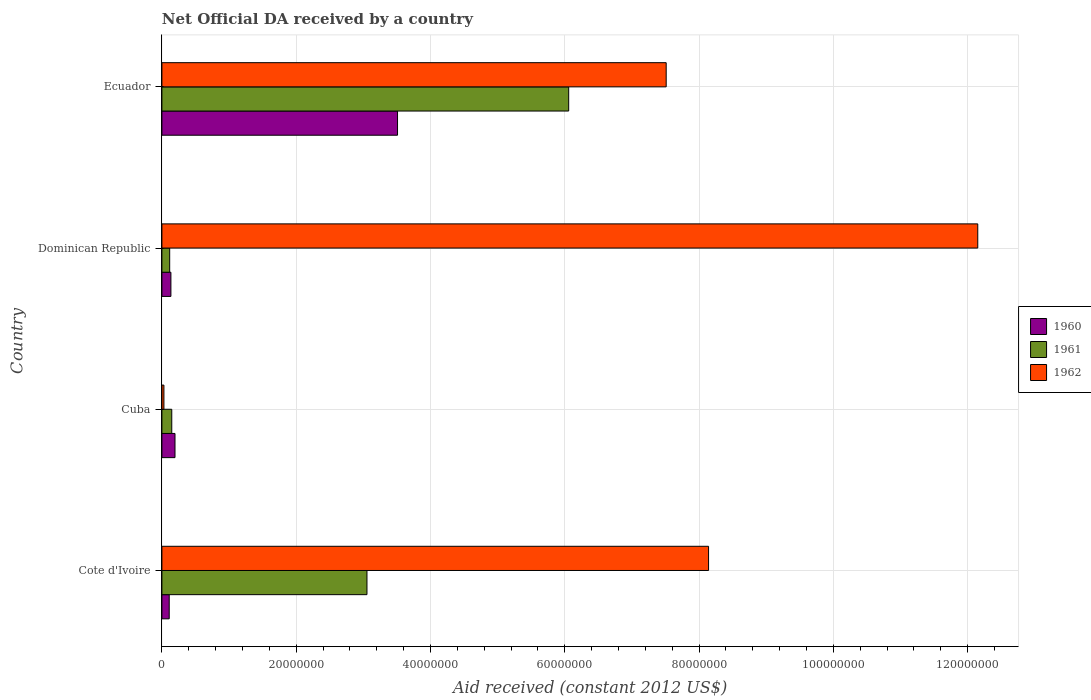How many groups of bars are there?
Provide a succinct answer. 4. How many bars are there on the 3rd tick from the bottom?
Your response must be concise. 3. What is the label of the 2nd group of bars from the top?
Your answer should be very brief. Dominican Republic. In how many cases, is the number of bars for a given country not equal to the number of legend labels?
Keep it short and to the point. 0. What is the net official development assistance aid received in 1960 in Dominican Republic?
Offer a terse response. 1.34e+06. Across all countries, what is the maximum net official development assistance aid received in 1960?
Offer a very short reply. 3.51e+07. Across all countries, what is the minimum net official development assistance aid received in 1961?
Your response must be concise. 1.16e+06. In which country was the net official development assistance aid received in 1961 maximum?
Provide a short and direct response. Ecuador. In which country was the net official development assistance aid received in 1962 minimum?
Give a very brief answer. Cuba. What is the total net official development assistance aid received in 1961 in the graph?
Ensure brevity in your answer.  9.38e+07. What is the difference between the net official development assistance aid received in 1961 in Cuba and that in Dominican Republic?
Provide a short and direct response. 3.10e+05. What is the difference between the net official development assistance aid received in 1960 in Cuba and the net official development assistance aid received in 1962 in Ecuador?
Offer a very short reply. -7.32e+07. What is the average net official development assistance aid received in 1962 per country?
Offer a terse response. 6.96e+07. What is the ratio of the net official development assistance aid received in 1960 in Cote d'Ivoire to that in Ecuador?
Give a very brief answer. 0.03. What is the difference between the highest and the second highest net official development assistance aid received in 1960?
Provide a short and direct response. 3.31e+07. What is the difference between the highest and the lowest net official development assistance aid received in 1960?
Your answer should be compact. 3.40e+07. Is the sum of the net official development assistance aid received in 1962 in Dominican Republic and Ecuador greater than the maximum net official development assistance aid received in 1960 across all countries?
Your answer should be very brief. Yes. Are all the bars in the graph horizontal?
Offer a terse response. Yes. How many countries are there in the graph?
Your answer should be compact. 4. What is the difference between two consecutive major ticks on the X-axis?
Offer a very short reply. 2.00e+07. Where does the legend appear in the graph?
Ensure brevity in your answer.  Center right. How many legend labels are there?
Your answer should be compact. 3. How are the legend labels stacked?
Provide a short and direct response. Vertical. What is the title of the graph?
Keep it short and to the point. Net Official DA received by a country. Does "1986" appear as one of the legend labels in the graph?
Offer a terse response. No. What is the label or title of the X-axis?
Make the answer very short. Aid received (constant 2012 US$). What is the label or title of the Y-axis?
Provide a short and direct response. Country. What is the Aid received (constant 2012 US$) in 1960 in Cote d'Ivoire?
Provide a short and direct response. 1.09e+06. What is the Aid received (constant 2012 US$) of 1961 in Cote d'Ivoire?
Give a very brief answer. 3.05e+07. What is the Aid received (constant 2012 US$) in 1962 in Cote d'Ivoire?
Your answer should be compact. 8.14e+07. What is the Aid received (constant 2012 US$) in 1960 in Cuba?
Your answer should be compact. 1.95e+06. What is the Aid received (constant 2012 US$) of 1961 in Cuba?
Make the answer very short. 1.47e+06. What is the Aid received (constant 2012 US$) in 1962 in Cuba?
Your answer should be very brief. 3.00e+05. What is the Aid received (constant 2012 US$) of 1960 in Dominican Republic?
Provide a succinct answer. 1.34e+06. What is the Aid received (constant 2012 US$) in 1961 in Dominican Republic?
Provide a short and direct response. 1.16e+06. What is the Aid received (constant 2012 US$) in 1962 in Dominican Republic?
Offer a very short reply. 1.22e+08. What is the Aid received (constant 2012 US$) of 1960 in Ecuador?
Keep it short and to the point. 3.51e+07. What is the Aid received (constant 2012 US$) in 1961 in Ecuador?
Keep it short and to the point. 6.06e+07. What is the Aid received (constant 2012 US$) of 1962 in Ecuador?
Offer a terse response. 7.51e+07. Across all countries, what is the maximum Aid received (constant 2012 US$) of 1960?
Provide a succinct answer. 3.51e+07. Across all countries, what is the maximum Aid received (constant 2012 US$) of 1961?
Keep it short and to the point. 6.06e+07. Across all countries, what is the maximum Aid received (constant 2012 US$) of 1962?
Keep it short and to the point. 1.22e+08. Across all countries, what is the minimum Aid received (constant 2012 US$) of 1960?
Make the answer very short. 1.09e+06. Across all countries, what is the minimum Aid received (constant 2012 US$) in 1961?
Ensure brevity in your answer.  1.16e+06. Across all countries, what is the minimum Aid received (constant 2012 US$) of 1962?
Provide a succinct answer. 3.00e+05. What is the total Aid received (constant 2012 US$) of 1960 in the graph?
Provide a short and direct response. 3.95e+07. What is the total Aid received (constant 2012 US$) of 1961 in the graph?
Ensure brevity in your answer.  9.38e+07. What is the total Aid received (constant 2012 US$) of 1962 in the graph?
Your answer should be compact. 2.78e+08. What is the difference between the Aid received (constant 2012 US$) of 1960 in Cote d'Ivoire and that in Cuba?
Ensure brevity in your answer.  -8.60e+05. What is the difference between the Aid received (constant 2012 US$) of 1961 in Cote d'Ivoire and that in Cuba?
Provide a succinct answer. 2.91e+07. What is the difference between the Aid received (constant 2012 US$) of 1962 in Cote d'Ivoire and that in Cuba?
Your answer should be very brief. 8.11e+07. What is the difference between the Aid received (constant 2012 US$) in 1960 in Cote d'Ivoire and that in Dominican Republic?
Offer a very short reply. -2.50e+05. What is the difference between the Aid received (constant 2012 US$) in 1961 in Cote d'Ivoire and that in Dominican Republic?
Your response must be concise. 2.94e+07. What is the difference between the Aid received (constant 2012 US$) of 1962 in Cote d'Ivoire and that in Dominican Republic?
Offer a terse response. -4.01e+07. What is the difference between the Aid received (constant 2012 US$) of 1960 in Cote d'Ivoire and that in Ecuador?
Keep it short and to the point. -3.40e+07. What is the difference between the Aid received (constant 2012 US$) of 1961 in Cote d'Ivoire and that in Ecuador?
Ensure brevity in your answer.  -3.00e+07. What is the difference between the Aid received (constant 2012 US$) in 1962 in Cote d'Ivoire and that in Ecuador?
Offer a terse response. 6.31e+06. What is the difference between the Aid received (constant 2012 US$) in 1961 in Cuba and that in Dominican Republic?
Ensure brevity in your answer.  3.10e+05. What is the difference between the Aid received (constant 2012 US$) in 1962 in Cuba and that in Dominican Republic?
Provide a succinct answer. -1.21e+08. What is the difference between the Aid received (constant 2012 US$) of 1960 in Cuba and that in Ecuador?
Your answer should be compact. -3.31e+07. What is the difference between the Aid received (constant 2012 US$) in 1961 in Cuba and that in Ecuador?
Your answer should be very brief. -5.91e+07. What is the difference between the Aid received (constant 2012 US$) in 1962 in Cuba and that in Ecuador?
Give a very brief answer. -7.48e+07. What is the difference between the Aid received (constant 2012 US$) of 1960 in Dominican Republic and that in Ecuador?
Your answer should be very brief. -3.38e+07. What is the difference between the Aid received (constant 2012 US$) of 1961 in Dominican Republic and that in Ecuador?
Your response must be concise. -5.94e+07. What is the difference between the Aid received (constant 2012 US$) in 1962 in Dominican Republic and that in Ecuador?
Offer a terse response. 4.64e+07. What is the difference between the Aid received (constant 2012 US$) in 1960 in Cote d'Ivoire and the Aid received (constant 2012 US$) in 1961 in Cuba?
Make the answer very short. -3.80e+05. What is the difference between the Aid received (constant 2012 US$) of 1960 in Cote d'Ivoire and the Aid received (constant 2012 US$) of 1962 in Cuba?
Your response must be concise. 7.90e+05. What is the difference between the Aid received (constant 2012 US$) of 1961 in Cote d'Ivoire and the Aid received (constant 2012 US$) of 1962 in Cuba?
Make the answer very short. 3.02e+07. What is the difference between the Aid received (constant 2012 US$) of 1960 in Cote d'Ivoire and the Aid received (constant 2012 US$) of 1961 in Dominican Republic?
Make the answer very short. -7.00e+04. What is the difference between the Aid received (constant 2012 US$) in 1960 in Cote d'Ivoire and the Aid received (constant 2012 US$) in 1962 in Dominican Republic?
Your answer should be compact. -1.20e+08. What is the difference between the Aid received (constant 2012 US$) in 1961 in Cote d'Ivoire and the Aid received (constant 2012 US$) in 1962 in Dominican Republic?
Give a very brief answer. -9.10e+07. What is the difference between the Aid received (constant 2012 US$) in 1960 in Cote d'Ivoire and the Aid received (constant 2012 US$) in 1961 in Ecuador?
Your answer should be compact. -5.95e+07. What is the difference between the Aid received (constant 2012 US$) in 1960 in Cote d'Ivoire and the Aid received (constant 2012 US$) in 1962 in Ecuador?
Give a very brief answer. -7.40e+07. What is the difference between the Aid received (constant 2012 US$) of 1961 in Cote d'Ivoire and the Aid received (constant 2012 US$) of 1962 in Ecuador?
Keep it short and to the point. -4.46e+07. What is the difference between the Aid received (constant 2012 US$) in 1960 in Cuba and the Aid received (constant 2012 US$) in 1961 in Dominican Republic?
Keep it short and to the point. 7.90e+05. What is the difference between the Aid received (constant 2012 US$) of 1960 in Cuba and the Aid received (constant 2012 US$) of 1962 in Dominican Republic?
Ensure brevity in your answer.  -1.20e+08. What is the difference between the Aid received (constant 2012 US$) in 1961 in Cuba and the Aid received (constant 2012 US$) in 1962 in Dominican Republic?
Make the answer very short. -1.20e+08. What is the difference between the Aid received (constant 2012 US$) in 1960 in Cuba and the Aid received (constant 2012 US$) in 1961 in Ecuador?
Make the answer very short. -5.86e+07. What is the difference between the Aid received (constant 2012 US$) in 1960 in Cuba and the Aid received (constant 2012 US$) in 1962 in Ecuador?
Keep it short and to the point. -7.32e+07. What is the difference between the Aid received (constant 2012 US$) in 1961 in Cuba and the Aid received (constant 2012 US$) in 1962 in Ecuador?
Offer a very short reply. -7.36e+07. What is the difference between the Aid received (constant 2012 US$) in 1960 in Dominican Republic and the Aid received (constant 2012 US$) in 1961 in Ecuador?
Ensure brevity in your answer.  -5.92e+07. What is the difference between the Aid received (constant 2012 US$) of 1960 in Dominican Republic and the Aid received (constant 2012 US$) of 1962 in Ecuador?
Provide a succinct answer. -7.38e+07. What is the difference between the Aid received (constant 2012 US$) in 1961 in Dominican Republic and the Aid received (constant 2012 US$) in 1962 in Ecuador?
Offer a terse response. -7.39e+07. What is the average Aid received (constant 2012 US$) of 1960 per country?
Provide a short and direct response. 9.87e+06. What is the average Aid received (constant 2012 US$) in 1961 per country?
Your answer should be compact. 2.34e+07. What is the average Aid received (constant 2012 US$) of 1962 per country?
Keep it short and to the point. 6.96e+07. What is the difference between the Aid received (constant 2012 US$) in 1960 and Aid received (constant 2012 US$) in 1961 in Cote d'Ivoire?
Provide a short and direct response. -2.94e+07. What is the difference between the Aid received (constant 2012 US$) in 1960 and Aid received (constant 2012 US$) in 1962 in Cote d'Ivoire?
Offer a very short reply. -8.03e+07. What is the difference between the Aid received (constant 2012 US$) in 1961 and Aid received (constant 2012 US$) in 1962 in Cote d'Ivoire?
Provide a succinct answer. -5.09e+07. What is the difference between the Aid received (constant 2012 US$) in 1960 and Aid received (constant 2012 US$) in 1962 in Cuba?
Offer a very short reply. 1.65e+06. What is the difference between the Aid received (constant 2012 US$) of 1961 and Aid received (constant 2012 US$) of 1962 in Cuba?
Offer a terse response. 1.17e+06. What is the difference between the Aid received (constant 2012 US$) of 1960 and Aid received (constant 2012 US$) of 1962 in Dominican Republic?
Keep it short and to the point. -1.20e+08. What is the difference between the Aid received (constant 2012 US$) of 1961 and Aid received (constant 2012 US$) of 1962 in Dominican Republic?
Make the answer very short. -1.20e+08. What is the difference between the Aid received (constant 2012 US$) in 1960 and Aid received (constant 2012 US$) in 1961 in Ecuador?
Your answer should be very brief. -2.55e+07. What is the difference between the Aid received (constant 2012 US$) in 1960 and Aid received (constant 2012 US$) in 1962 in Ecuador?
Give a very brief answer. -4.00e+07. What is the difference between the Aid received (constant 2012 US$) of 1961 and Aid received (constant 2012 US$) of 1962 in Ecuador?
Ensure brevity in your answer.  -1.45e+07. What is the ratio of the Aid received (constant 2012 US$) in 1960 in Cote d'Ivoire to that in Cuba?
Provide a succinct answer. 0.56. What is the ratio of the Aid received (constant 2012 US$) in 1961 in Cote d'Ivoire to that in Cuba?
Give a very brief answer. 20.78. What is the ratio of the Aid received (constant 2012 US$) of 1962 in Cote d'Ivoire to that in Cuba?
Provide a short and direct response. 271.37. What is the ratio of the Aid received (constant 2012 US$) of 1960 in Cote d'Ivoire to that in Dominican Republic?
Your response must be concise. 0.81. What is the ratio of the Aid received (constant 2012 US$) of 1961 in Cote d'Ivoire to that in Dominican Republic?
Your answer should be compact. 26.33. What is the ratio of the Aid received (constant 2012 US$) of 1962 in Cote d'Ivoire to that in Dominican Republic?
Your response must be concise. 0.67. What is the ratio of the Aid received (constant 2012 US$) of 1960 in Cote d'Ivoire to that in Ecuador?
Make the answer very short. 0.03. What is the ratio of the Aid received (constant 2012 US$) in 1961 in Cote d'Ivoire to that in Ecuador?
Provide a short and direct response. 0.5. What is the ratio of the Aid received (constant 2012 US$) in 1962 in Cote d'Ivoire to that in Ecuador?
Offer a very short reply. 1.08. What is the ratio of the Aid received (constant 2012 US$) in 1960 in Cuba to that in Dominican Republic?
Keep it short and to the point. 1.46. What is the ratio of the Aid received (constant 2012 US$) in 1961 in Cuba to that in Dominican Republic?
Offer a very short reply. 1.27. What is the ratio of the Aid received (constant 2012 US$) of 1962 in Cuba to that in Dominican Republic?
Ensure brevity in your answer.  0. What is the ratio of the Aid received (constant 2012 US$) of 1960 in Cuba to that in Ecuador?
Your answer should be compact. 0.06. What is the ratio of the Aid received (constant 2012 US$) of 1961 in Cuba to that in Ecuador?
Your answer should be compact. 0.02. What is the ratio of the Aid received (constant 2012 US$) in 1962 in Cuba to that in Ecuador?
Your answer should be compact. 0. What is the ratio of the Aid received (constant 2012 US$) of 1960 in Dominican Republic to that in Ecuador?
Make the answer very short. 0.04. What is the ratio of the Aid received (constant 2012 US$) in 1961 in Dominican Republic to that in Ecuador?
Give a very brief answer. 0.02. What is the ratio of the Aid received (constant 2012 US$) in 1962 in Dominican Republic to that in Ecuador?
Offer a terse response. 1.62. What is the difference between the highest and the second highest Aid received (constant 2012 US$) in 1960?
Provide a short and direct response. 3.31e+07. What is the difference between the highest and the second highest Aid received (constant 2012 US$) of 1961?
Provide a short and direct response. 3.00e+07. What is the difference between the highest and the second highest Aid received (constant 2012 US$) of 1962?
Keep it short and to the point. 4.01e+07. What is the difference between the highest and the lowest Aid received (constant 2012 US$) of 1960?
Make the answer very short. 3.40e+07. What is the difference between the highest and the lowest Aid received (constant 2012 US$) in 1961?
Keep it short and to the point. 5.94e+07. What is the difference between the highest and the lowest Aid received (constant 2012 US$) in 1962?
Your response must be concise. 1.21e+08. 